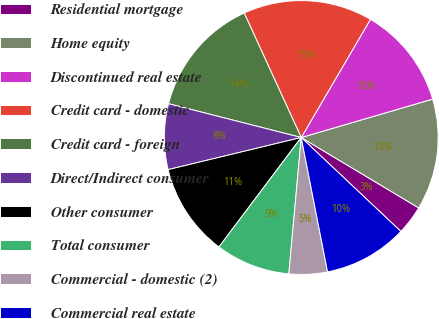Convert chart. <chart><loc_0><loc_0><loc_500><loc_500><pie_chart><fcel>Residential mortgage<fcel>Home equity<fcel>Discontinued real estate<fcel>Credit card - domestic<fcel>Credit card - foreign<fcel>Direct/Indirect consumer<fcel>Other consumer<fcel>Total consumer<fcel>Commercial - domestic (2)<fcel>Commercial real estate<nl><fcel>3.44%<fcel>13.12%<fcel>12.04%<fcel>15.27%<fcel>14.19%<fcel>7.74%<fcel>10.97%<fcel>8.82%<fcel>4.52%<fcel>9.89%<nl></chart> 